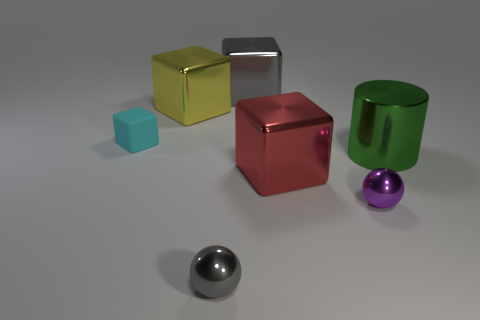Do the gray metal block and the cyan matte object have the same size?
Offer a very short reply. No. How many blocks are either cyan matte things or large yellow objects?
Make the answer very short. 2. What number of large blocks are to the left of the gray object in front of the tiny purple metal sphere?
Offer a very short reply. 1. Is the shape of the red object the same as the cyan object?
Give a very brief answer. Yes. There is another metallic object that is the same shape as the tiny gray thing; what size is it?
Your response must be concise. Small. What shape is the tiny metal object to the right of the large block in front of the yellow shiny cube?
Provide a succinct answer. Sphere. How big is the cylinder?
Your answer should be very brief. Large. The big gray metallic thing is what shape?
Make the answer very short. Cube. Does the red metallic object have the same shape as the large metallic object on the left side of the gray shiny cube?
Offer a very short reply. Yes. Do the yellow object on the left side of the large green thing and the green object have the same shape?
Make the answer very short. No. 